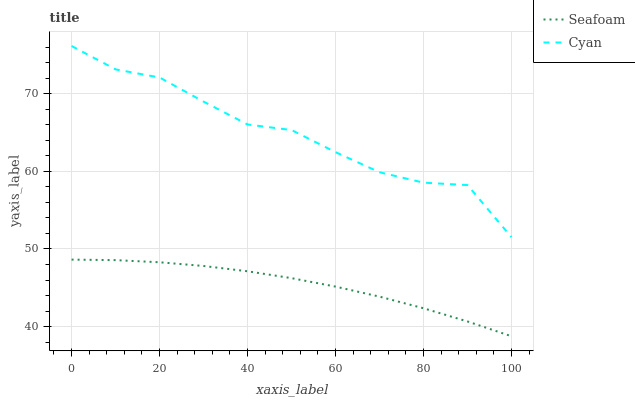Does Seafoam have the minimum area under the curve?
Answer yes or no. Yes. Does Cyan have the maximum area under the curve?
Answer yes or no. Yes. Does Seafoam have the maximum area under the curve?
Answer yes or no. No. Is Seafoam the smoothest?
Answer yes or no. Yes. Is Cyan the roughest?
Answer yes or no. Yes. Is Seafoam the roughest?
Answer yes or no. No. Does Seafoam have the highest value?
Answer yes or no. No. Is Seafoam less than Cyan?
Answer yes or no. Yes. Is Cyan greater than Seafoam?
Answer yes or no. Yes. Does Seafoam intersect Cyan?
Answer yes or no. No. 